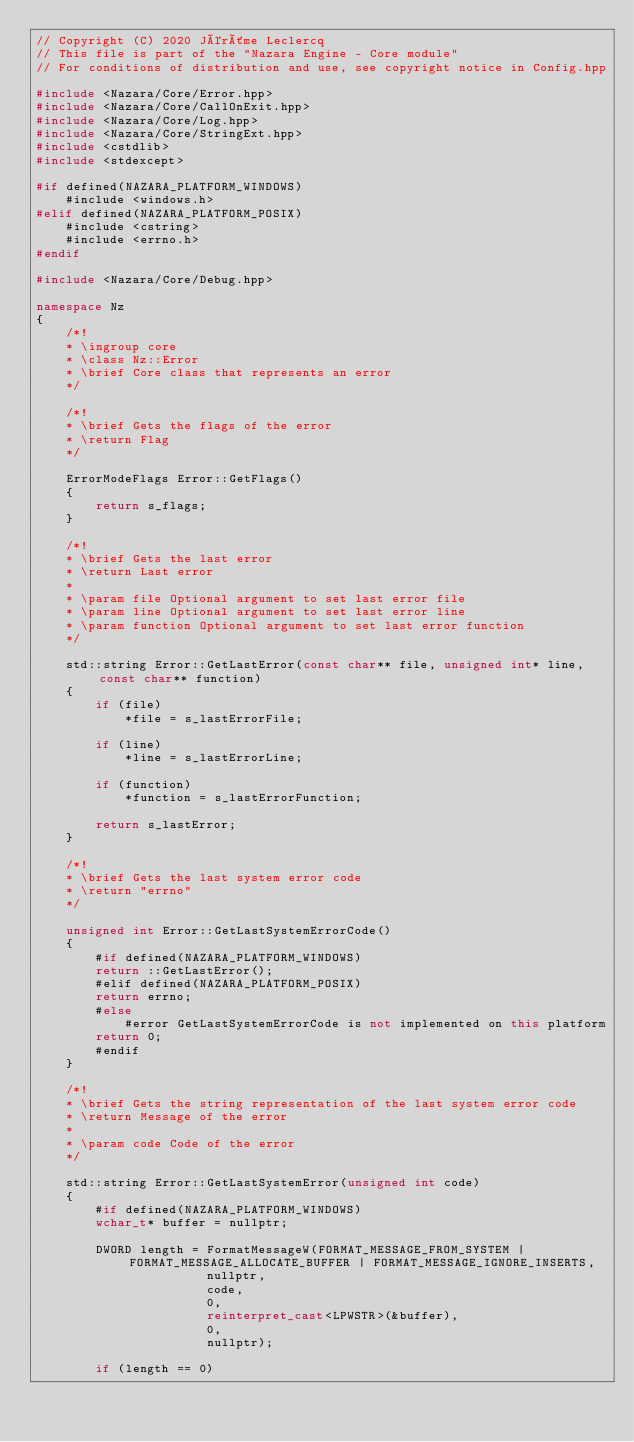Convert code to text. <code><loc_0><loc_0><loc_500><loc_500><_C++_>// Copyright (C) 2020 Jérôme Leclercq
// This file is part of the "Nazara Engine - Core module"
// For conditions of distribution and use, see copyright notice in Config.hpp

#include <Nazara/Core/Error.hpp>
#include <Nazara/Core/CallOnExit.hpp>
#include <Nazara/Core/Log.hpp>
#include <Nazara/Core/StringExt.hpp>
#include <cstdlib>
#include <stdexcept>

#if defined(NAZARA_PLATFORM_WINDOWS)
	#include <windows.h>
#elif defined(NAZARA_PLATFORM_POSIX)
	#include <cstring>
	#include <errno.h>
#endif

#include <Nazara/Core/Debug.hpp>

namespace Nz
{
	/*!
	* \ingroup core
	* \class Nz::Error
	* \brief Core class that represents an error
	*/

	/*!
	* \brief Gets the flags of the error
	* \return Flag
	*/

	ErrorModeFlags Error::GetFlags()
	{
		return s_flags;
	}

	/*!
	* \brief Gets the last error
	* \return Last error
	*
	* \param file Optional argument to set last error file
	* \param line Optional argument to set last error line
	* \param function Optional argument to set last error function
	*/

	std::string Error::GetLastError(const char** file, unsigned int* line, const char** function)
	{
		if (file)
			*file = s_lastErrorFile;

		if (line)
			*line = s_lastErrorLine;

		if (function)
			*function = s_lastErrorFunction;

		return s_lastError;
	}

	/*!
	* \brief Gets the last system error code
	* \return "errno"
	*/

	unsigned int Error::GetLastSystemErrorCode()
	{
		#if defined(NAZARA_PLATFORM_WINDOWS)
		return ::GetLastError();
		#elif defined(NAZARA_PLATFORM_POSIX)
		return errno;
		#else
			#error GetLastSystemErrorCode is not implemented on this platform
		return 0;
		#endif
	}

	/*!
	* \brief Gets the string representation of the last system error code
	* \return Message of the error
	*
	* \param code Code of the error
	*/

	std::string Error::GetLastSystemError(unsigned int code)
	{
		#if defined(NAZARA_PLATFORM_WINDOWS)
		wchar_t* buffer = nullptr;

		DWORD length = FormatMessageW(FORMAT_MESSAGE_FROM_SYSTEM | FORMAT_MESSAGE_ALLOCATE_BUFFER | FORMAT_MESSAGE_IGNORE_INSERTS,
		               nullptr,
		               code,
		               0,
		               reinterpret_cast<LPWSTR>(&buffer),
		               0,
		               nullptr);

		if (length == 0)</code> 